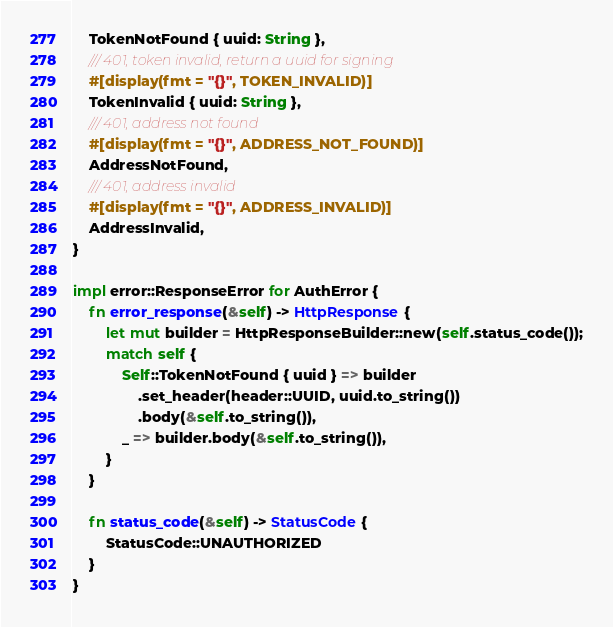Convert code to text. <code><loc_0><loc_0><loc_500><loc_500><_Rust_>    TokenNotFound { uuid: String },
    /// 401, token invalid, return a uuid for signing
    #[display(fmt = "{}", TOKEN_INVALID)]
    TokenInvalid { uuid: String },
    /// 401, address not found
    #[display(fmt = "{}", ADDRESS_NOT_FOUND)]
    AddressNotFound,
    /// 401, address invalid
    #[display(fmt = "{}", ADDRESS_INVALID)]
    AddressInvalid,
}

impl error::ResponseError for AuthError {
    fn error_response(&self) -> HttpResponse {
        let mut builder = HttpResponseBuilder::new(self.status_code());
        match self {
            Self::TokenNotFound { uuid } => builder
                .set_header(header::UUID, uuid.to_string())
                .body(&self.to_string()),
            _ => builder.body(&self.to_string()),
        }
    }

    fn status_code(&self) -> StatusCode {
        StatusCode::UNAUTHORIZED
    }
}
</code> 